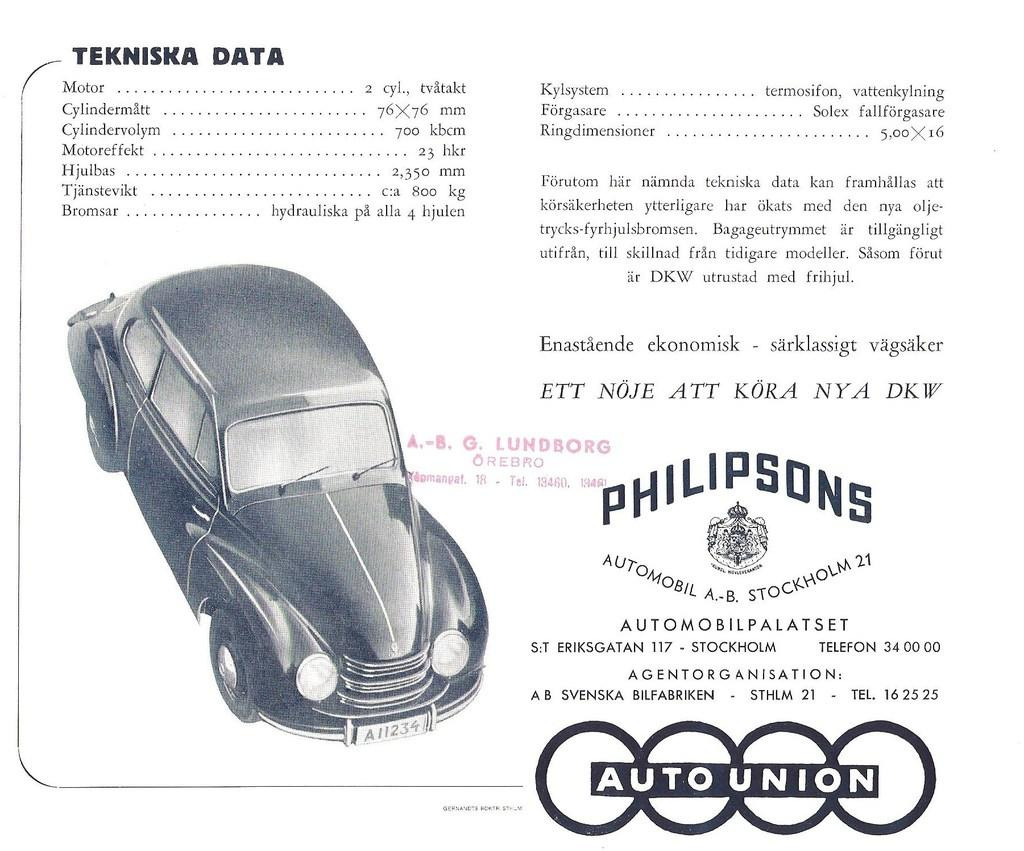What can be seen on the wall in the image? There is a poster in the image. How many worms can be seen crawling on the poster in the image? There are no worms present on the poster in the image. What type of comb is used to style the donkey's hair in the image? There is no donkey or comb present in the image. 